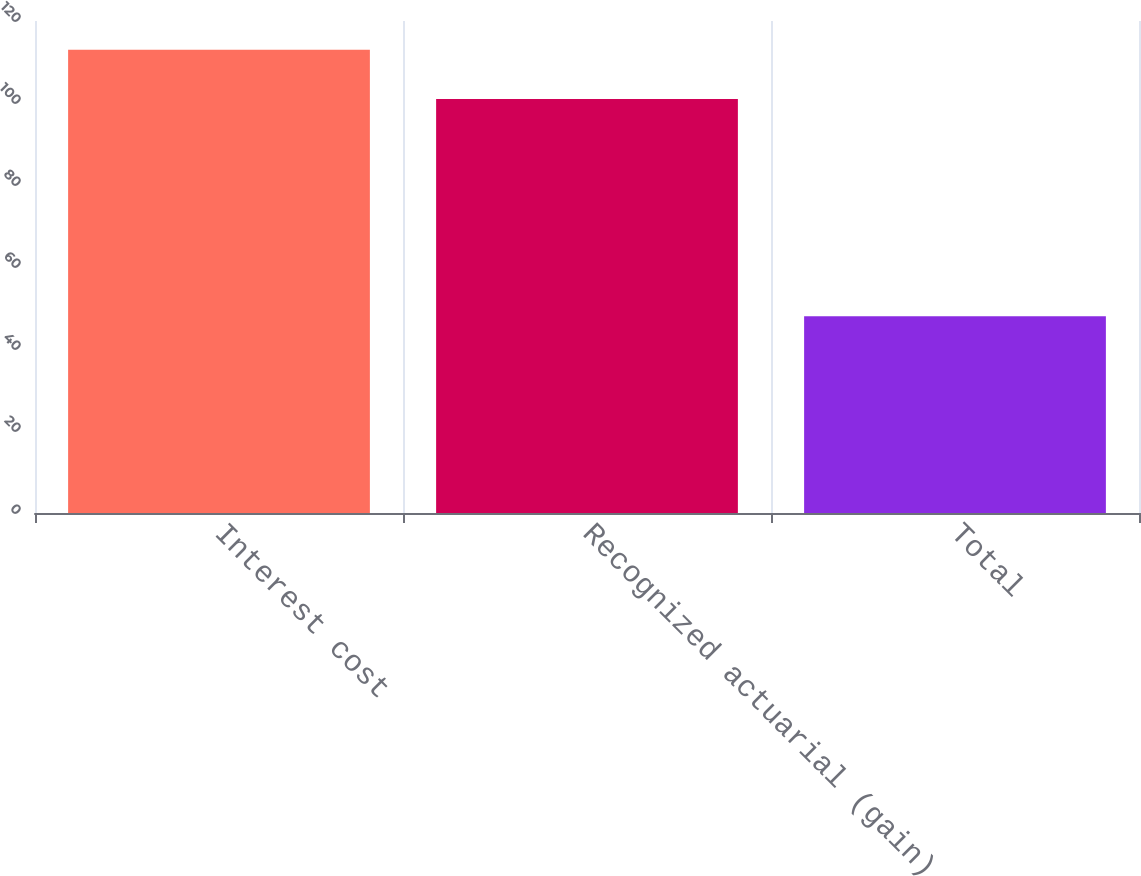Convert chart. <chart><loc_0><loc_0><loc_500><loc_500><bar_chart><fcel>Interest cost<fcel>Recognized actuarial (gain)<fcel>Total<nl><fcel>113<fcel>101<fcel>48<nl></chart> 